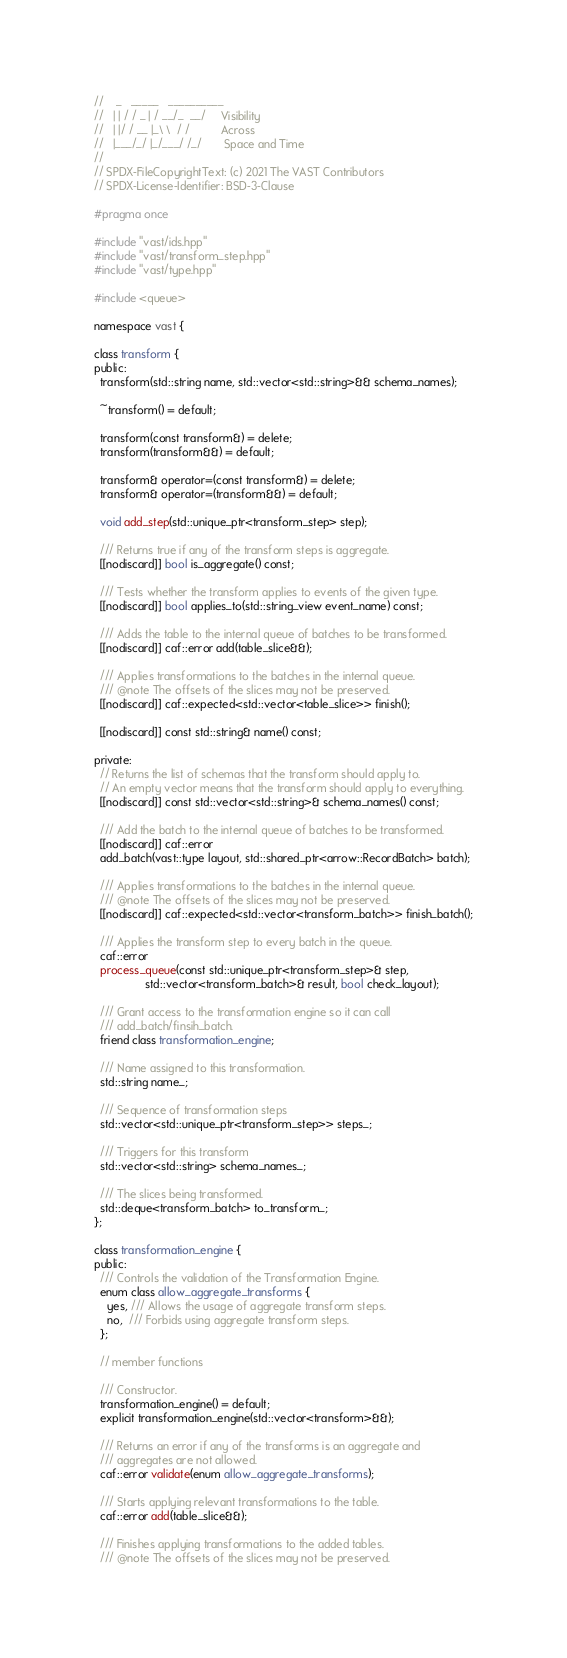Convert code to text. <code><loc_0><loc_0><loc_500><loc_500><_C++_>//    _   _____   __________
//   | | / / _ | / __/_  __/     Visibility
//   | |/ / __ |_\ \  / /          Across
//   |___/_/ |_/___/ /_/       Space and Time
//
// SPDX-FileCopyrightText: (c) 2021 The VAST Contributors
// SPDX-License-Identifier: BSD-3-Clause

#pragma once

#include "vast/ids.hpp"
#include "vast/transform_step.hpp"
#include "vast/type.hpp"

#include <queue>

namespace vast {

class transform {
public:
  transform(std::string name, std::vector<std::string>&& schema_names);

  ~transform() = default;

  transform(const transform&) = delete;
  transform(transform&&) = default;

  transform& operator=(const transform&) = delete;
  transform& operator=(transform&&) = default;

  void add_step(std::unique_ptr<transform_step> step);

  /// Returns true if any of the transform steps is aggregate.
  [[nodiscard]] bool is_aggregate() const;

  /// Tests whether the transform applies to events of the given type.
  [[nodiscard]] bool applies_to(std::string_view event_name) const;

  /// Adds the table to the internal queue of batches to be transformed.
  [[nodiscard]] caf::error add(table_slice&&);

  /// Applies transformations to the batches in the internal queue.
  /// @note The offsets of the slices may not be preserved.
  [[nodiscard]] caf::expected<std::vector<table_slice>> finish();

  [[nodiscard]] const std::string& name() const;

private:
  // Returns the list of schemas that the transform should apply to.
  // An empty vector means that the transform should apply to everything.
  [[nodiscard]] const std::vector<std::string>& schema_names() const;

  /// Add the batch to the internal queue of batches to be transformed.
  [[nodiscard]] caf::error
  add_batch(vast::type layout, std::shared_ptr<arrow::RecordBatch> batch);

  /// Applies transformations to the batches in the internal queue.
  /// @note The offsets of the slices may not be preserved.
  [[nodiscard]] caf::expected<std::vector<transform_batch>> finish_batch();

  /// Applies the transform step to every batch in the queue.
  caf::error
  process_queue(const std::unique_ptr<transform_step>& step,
                std::vector<transform_batch>& result, bool check_layout);

  /// Grant access to the transformation engine so it can call
  /// add_batch/finsih_batch.
  friend class transformation_engine;

  /// Name assigned to this transformation.
  std::string name_;

  /// Sequence of transformation steps
  std::vector<std::unique_ptr<transform_step>> steps_;

  /// Triggers for this transform
  std::vector<std::string> schema_names_;

  /// The slices being transformed.
  std::deque<transform_batch> to_transform_;
};

class transformation_engine {
public:
  /// Controls the validation of the Transformation Engine.
  enum class allow_aggregate_transforms {
    yes, /// Allows the usage of aggregate transform steps.
    no,  /// Forbids using aggregate transform steps.
  };

  // member functions

  /// Constructor.
  transformation_engine() = default;
  explicit transformation_engine(std::vector<transform>&&);

  /// Returns an error if any of the transforms is an aggregate and
  /// aggregates are not allowed.
  caf::error validate(enum allow_aggregate_transforms);

  /// Starts applying relevant transformations to the table.
  caf::error add(table_slice&&);

  /// Finishes applying transformations to the added tables.
  /// @note The offsets of the slices may not be preserved.</code> 